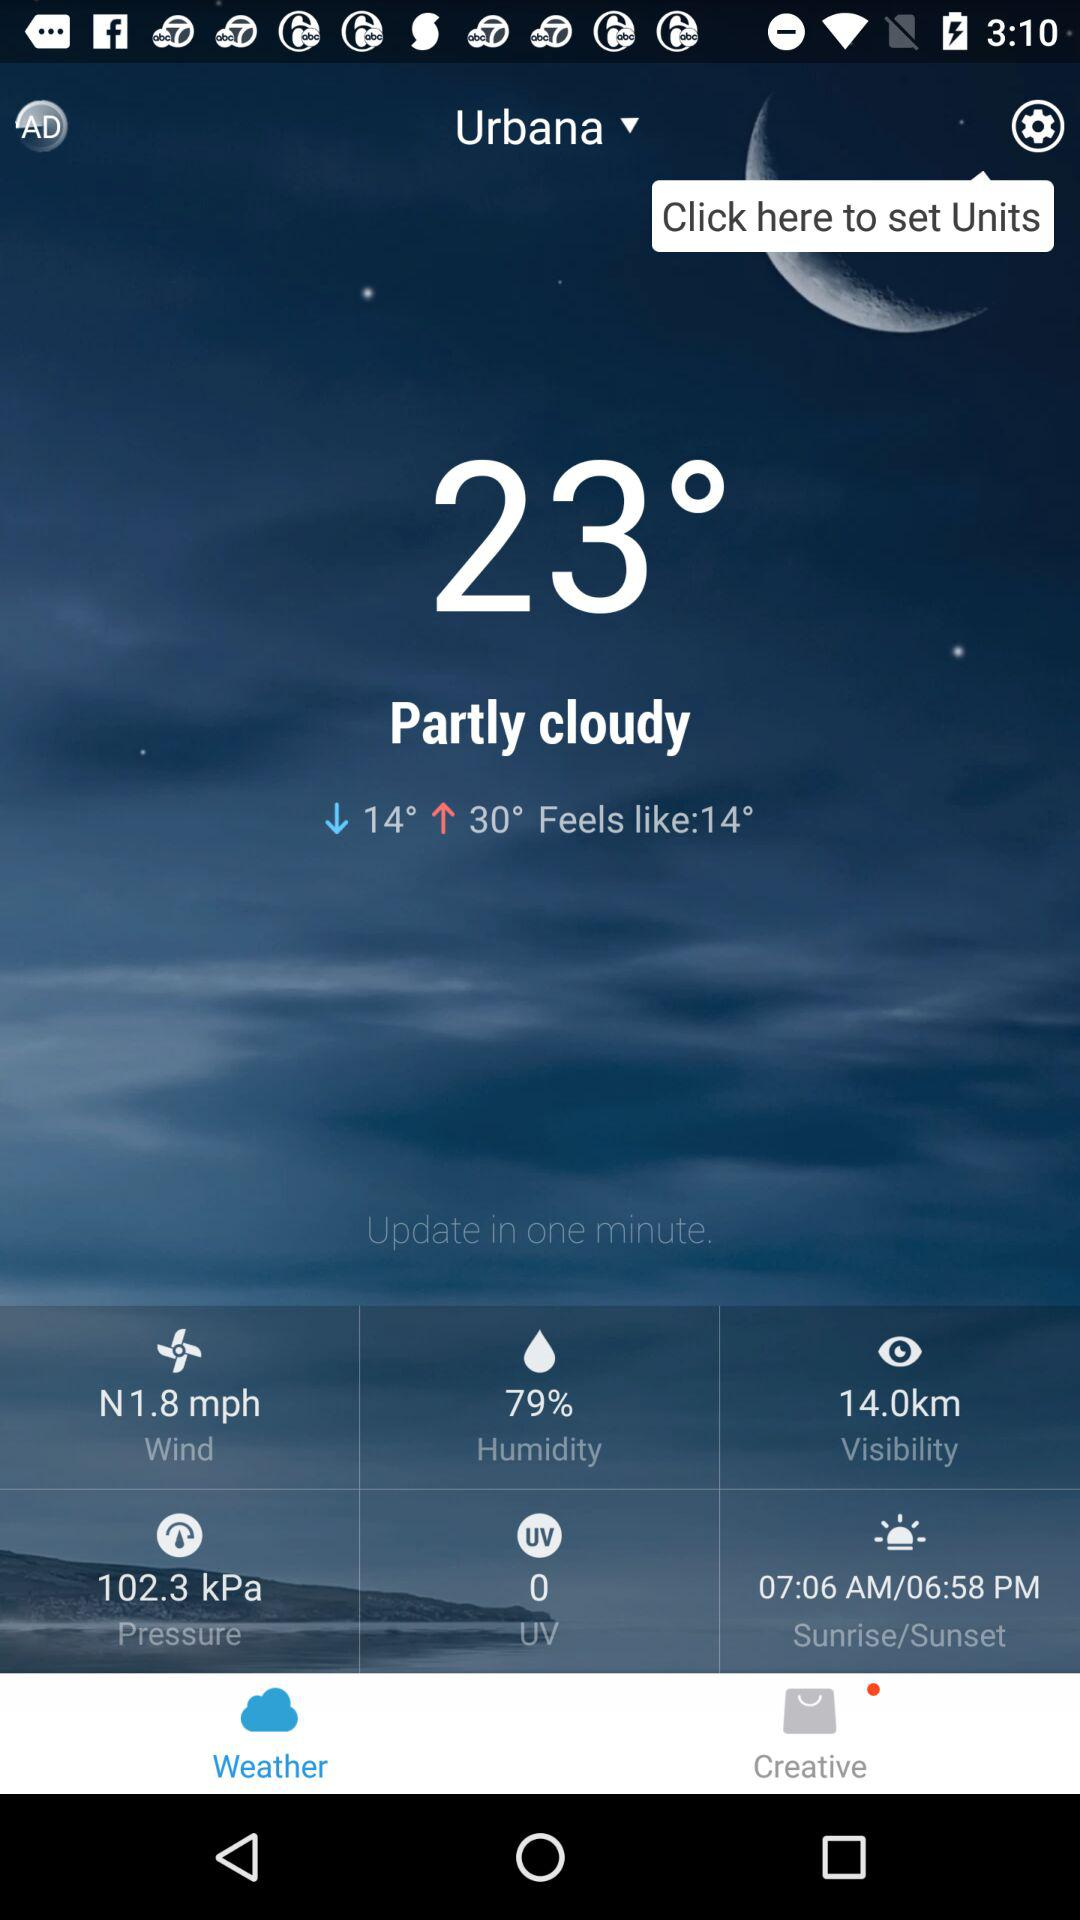What is the humidity percentage?
Answer the question using a single word or phrase. 79% 